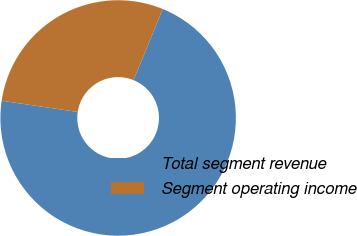<chart> <loc_0><loc_0><loc_500><loc_500><pie_chart><fcel>Total segment revenue<fcel>Segment operating income<nl><fcel>71.15%<fcel>28.85%<nl></chart> 